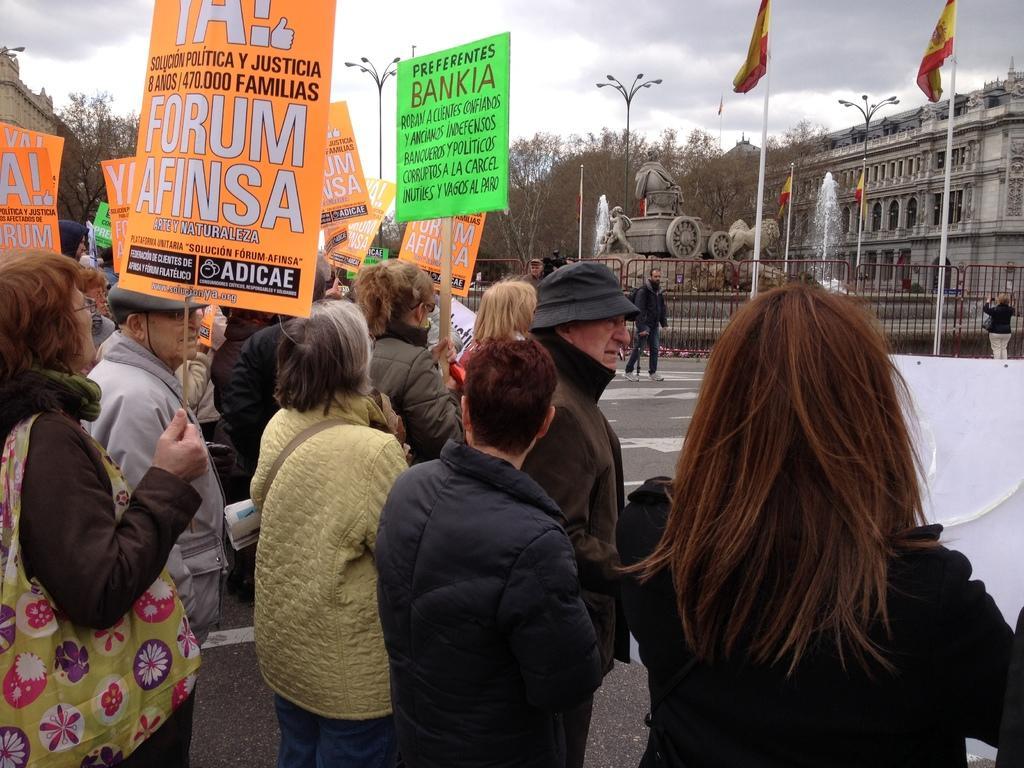Could you give a brief overview of what you see in this image? In this image I can see the group of people and few people are holding colorful boards. Back I can see few buildings, windows, light poles, fountains, statue, dry trees, flags and the fencing. The sky is in blue and white color. 